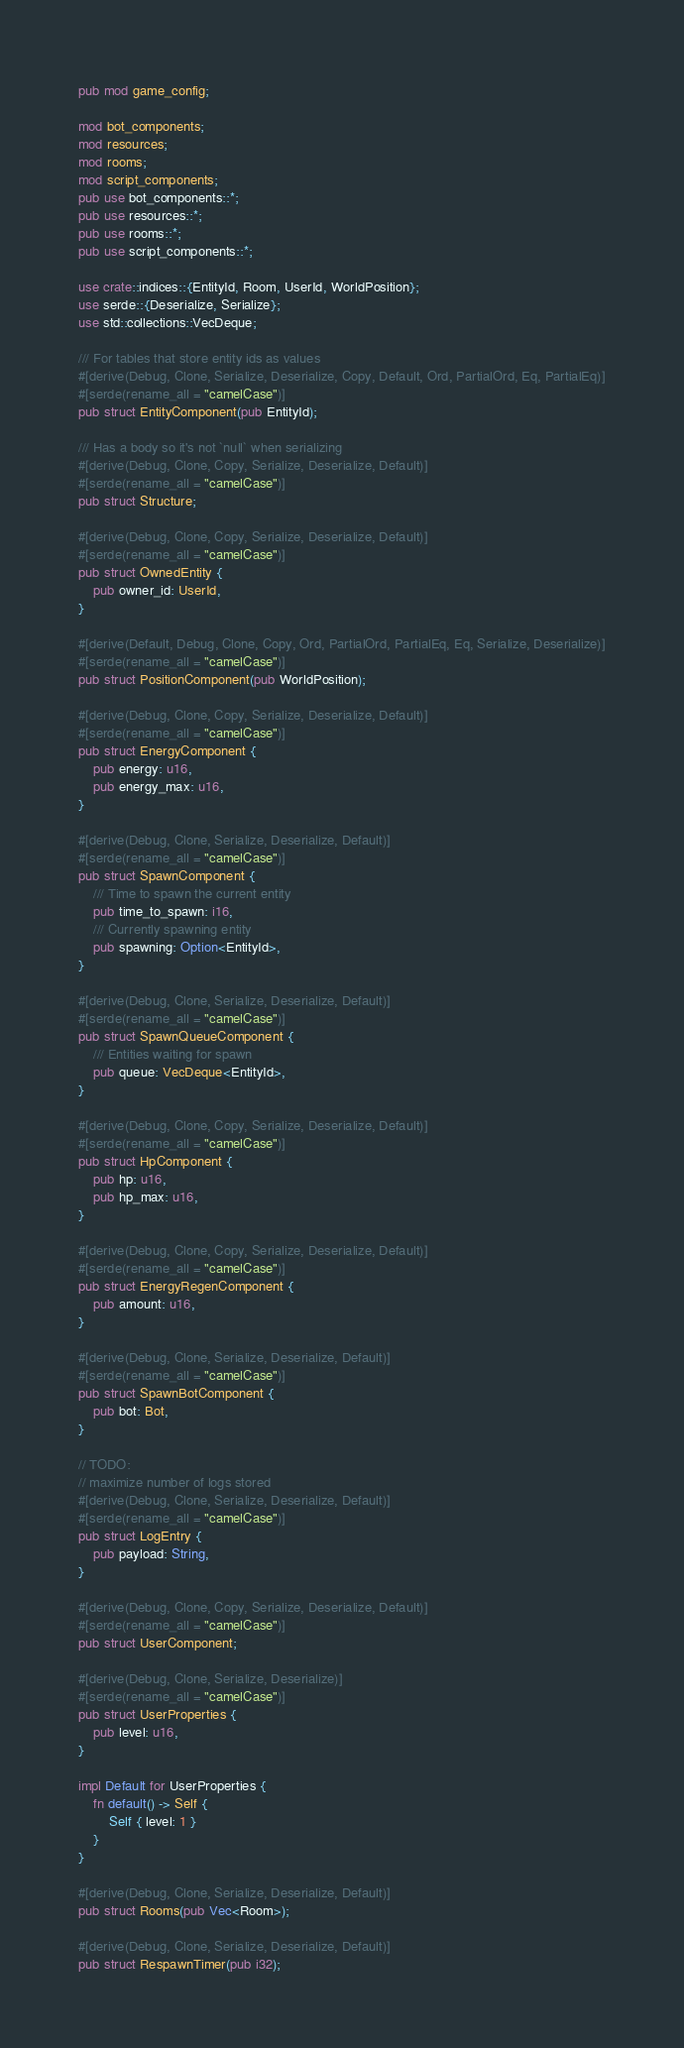<code> <loc_0><loc_0><loc_500><loc_500><_Rust_>pub mod game_config;

mod bot_components;
mod resources;
mod rooms;
mod script_components;
pub use bot_components::*;
pub use resources::*;
pub use rooms::*;
pub use script_components::*;

use crate::indices::{EntityId, Room, UserId, WorldPosition};
use serde::{Deserialize, Serialize};
use std::collections::VecDeque;

/// For tables that store entity ids as values
#[derive(Debug, Clone, Serialize, Deserialize, Copy, Default, Ord, PartialOrd, Eq, PartialEq)]
#[serde(rename_all = "camelCase")]
pub struct EntityComponent(pub EntityId);

/// Has a body so it's not `null` when serializing
#[derive(Debug, Clone, Copy, Serialize, Deserialize, Default)]
#[serde(rename_all = "camelCase")]
pub struct Structure;

#[derive(Debug, Clone, Copy, Serialize, Deserialize, Default)]
#[serde(rename_all = "camelCase")]
pub struct OwnedEntity {
    pub owner_id: UserId,
}

#[derive(Default, Debug, Clone, Copy, Ord, PartialOrd, PartialEq, Eq, Serialize, Deserialize)]
#[serde(rename_all = "camelCase")]
pub struct PositionComponent(pub WorldPosition);

#[derive(Debug, Clone, Copy, Serialize, Deserialize, Default)]
#[serde(rename_all = "camelCase")]
pub struct EnergyComponent {
    pub energy: u16,
    pub energy_max: u16,
}

#[derive(Debug, Clone, Serialize, Deserialize, Default)]
#[serde(rename_all = "camelCase")]
pub struct SpawnComponent {
    /// Time to spawn the current entity
    pub time_to_spawn: i16,
    /// Currently spawning entity
    pub spawning: Option<EntityId>,
}

#[derive(Debug, Clone, Serialize, Deserialize, Default)]
#[serde(rename_all = "camelCase")]
pub struct SpawnQueueComponent {
    /// Entities waiting for spawn
    pub queue: VecDeque<EntityId>,
}

#[derive(Debug, Clone, Copy, Serialize, Deserialize, Default)]
#[serde(rename_all = "camelCase")]
pub struct HpComponent {
    pub hp: u16,
    pub hp_max: u16,
}

#[derive(Debug, Clone, Copy, Serialize, Deserialize, Default)]
#[serde(rename_all = "camelCase")]
pub struct EnergyRegenComponent {
    pub amount: u16,
}

#[derive(Debug, Clone, Serialize, Deserialize, Default)]
#[serde(rename_all = "camelCase")]
pub struct SpawnBotComponent {
    pub bot: Bot,
}

// TODO:
// maximize number of logs stored
#[derive(Debug, Clone, Serialize, Deserialize, Default)]
#[serde(rename_all = "camelCase")]
pub struct LogEntry {
    pub payload: String,
}

#[derive(Debug, Clone, Copy, Serialize, Deserialize, Default)]
#[serde(rename_all = "camelCase")]
pub struct UserComponent;

#[derive(Debug, Clone, Serialize, Deserialize)]
#[serde(rename_all = "camelCase")]
pub struct UserProperties {
    pub level: u16,
}

impl Default for UserProperties {
    fn default() -> Self {
        Self { level: 1 }
    }
}

#[derive(Debug, Clone, Serialize, Deserialize, Default)]
pub struct Rooms(pub Vec<Room>);

#[derive(Debug, Clone, Serialize, Deserialize, Default)]
pub struct RespawnTimer(pub i32);
</code> 